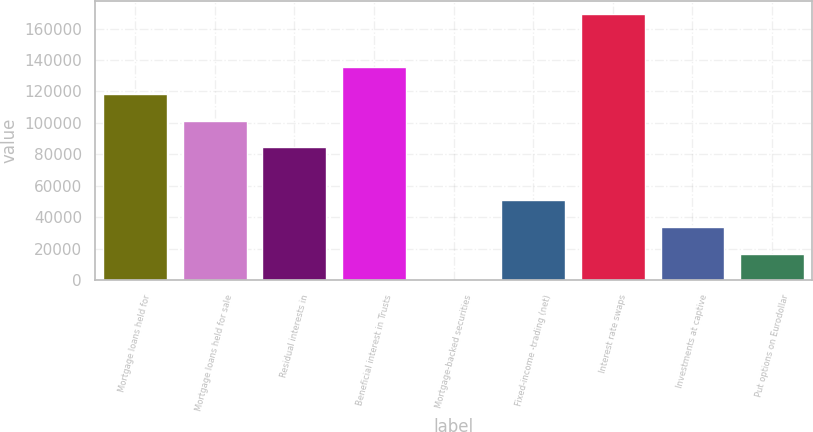Convert chart to OTSL. <chart><loc_0><loc_0><loc_500><loc_500><bar_chart><fcel>Mortgage loans held for<fcel>Mortgage loans held for sale<fcel>Residual interests in<fcel>Beneficial interest in Trusts<fcel>Mortgage-backed securities<fcel>Fixed-income -trading (net)<fcel>Interest rate swaps<fcel>Investments at captive<fcel>Put options on Eurodollar<nl><fcel>118398<fcel>101490<fcel>84582.5<fcel>135305<fcel>45<fcel>50767.5<fcel>169120<fcel>33860<fcel>16952.5<nl></chart> 